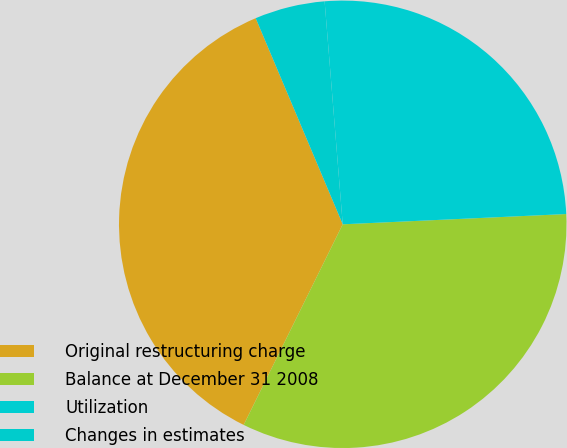Convert chart to OTSL. <chart><loc_0><loc_0><loc_500><loc_500><pie_chart><fcel>Original restructuring charge<fcel>Balance at December 31 2008<fcel>Utilization<fcel>Changes in estimates<nl><fcel>36.34%<fcel>33.03%<fcel>25.56%<fcel>5.07%<nl></chart> 